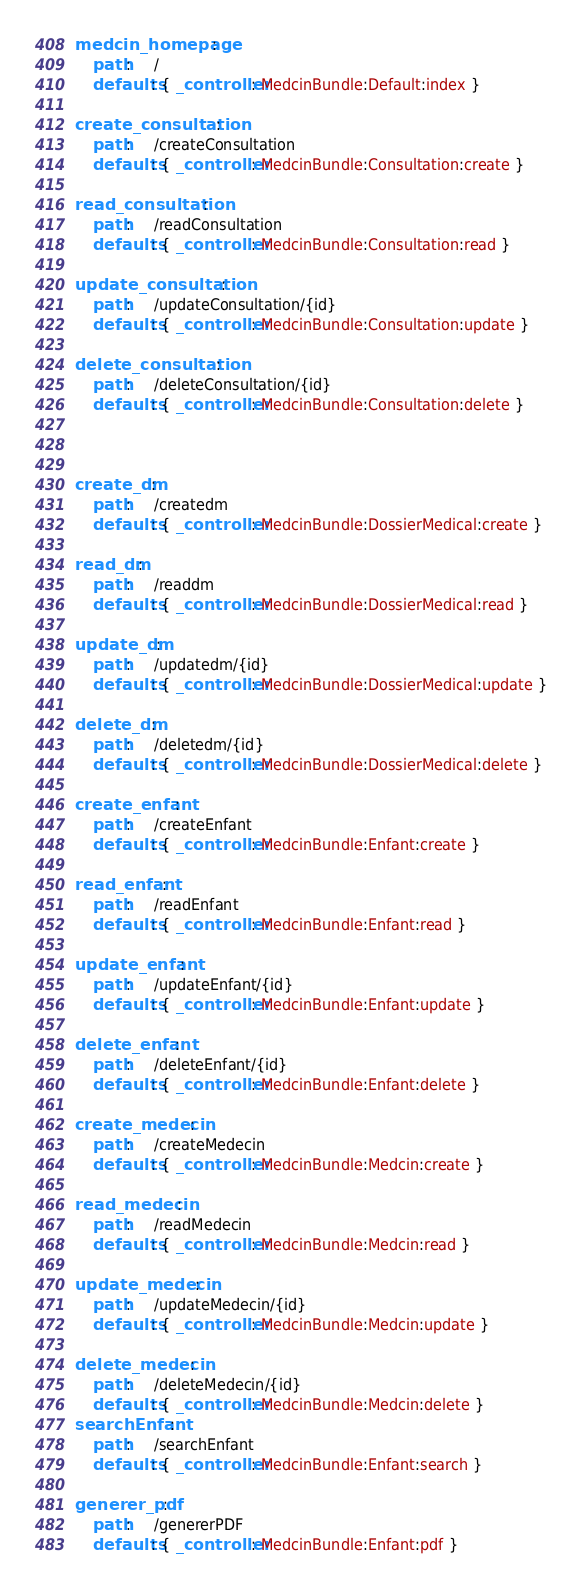<code> <loc_0><loc_0><loc_500><loc_500><_YAML_>medcin_homepage:
    path:     /
    defaults: { _controller: MedcinBundle:Default:index }

create_consultation:
    path:     /createConsultation
    defaults: { _controller: MedcinBundle:Consultation:create }

read_consultation:
    path:     /readConsultation
    defaults: { _controller: MedcinBundle:Consultation:read }

update_consultation:
    path:     /updateConsultation/{id}
    defaults: { _controller: MedcinBundle:Consultation:update }

delete_consultation:
    path:     /deleteConsultation/{id}
    defaults: { _controller: MedcinBundle:Consultation:delete }



create_dm:
    path:     /createdm
    defaults: { _controller: MedcinBundle:DossierMedical:create }

read_dm:
    path:     /readdm
    defaults: { _controller: MedcinBundle:DossierMedical:read }

update_dm:
    path:     /updatedm/{id}
    defaults: { _controller: MedcinBundle:DossierMedical:update }

delete_dm:
    path:     /deletedm/{id}
    defaults: { _controller: MedcinBundle:DossierMedical:delete }

create_enfant:
    path:     /createEnfant
    defaults: { _controller: MedcinBundle:Enfant:create }

read_enfant:
    path:     /readEnfant
    defaults: { _controller: MedcinBundle:Enfant:read }

update_enfant:
    path:     /updateEnfant/{id}
    defaults: { _controller: MedcinBundle:Enfant:update }

delete_enfant:
    path:     /deleteEnfant/{id}
    defaults: { _controller: MedcinBundle:Enfant:delete }

create_medecin:
    path:     /createMedecin
    defaults: { _controller: MedcinBundle:Medcin:create }

read_medecin:
    path:     /readMedecin
    defaults: { _controller: MedcinBundle:Medcin:read }

update_medecin:
    path:     /updateMedecin/{id}
    defaults: { _controller: MedcinBundle:Medcin:update }

delete_medecin:
    path:     /deleteMedecin/{id}
    defaults: { _controller: MedcinBundle:Medcin:delete }
searchEnfant:
    path:     /searchEnfant
    defaults: { _controller: MedcinBundle:Enfant:search }

generer_pdf:
    path:     /genererPDF
    defaults: { _controller: MedcinBundle:Enfant:pdf }
</code> 